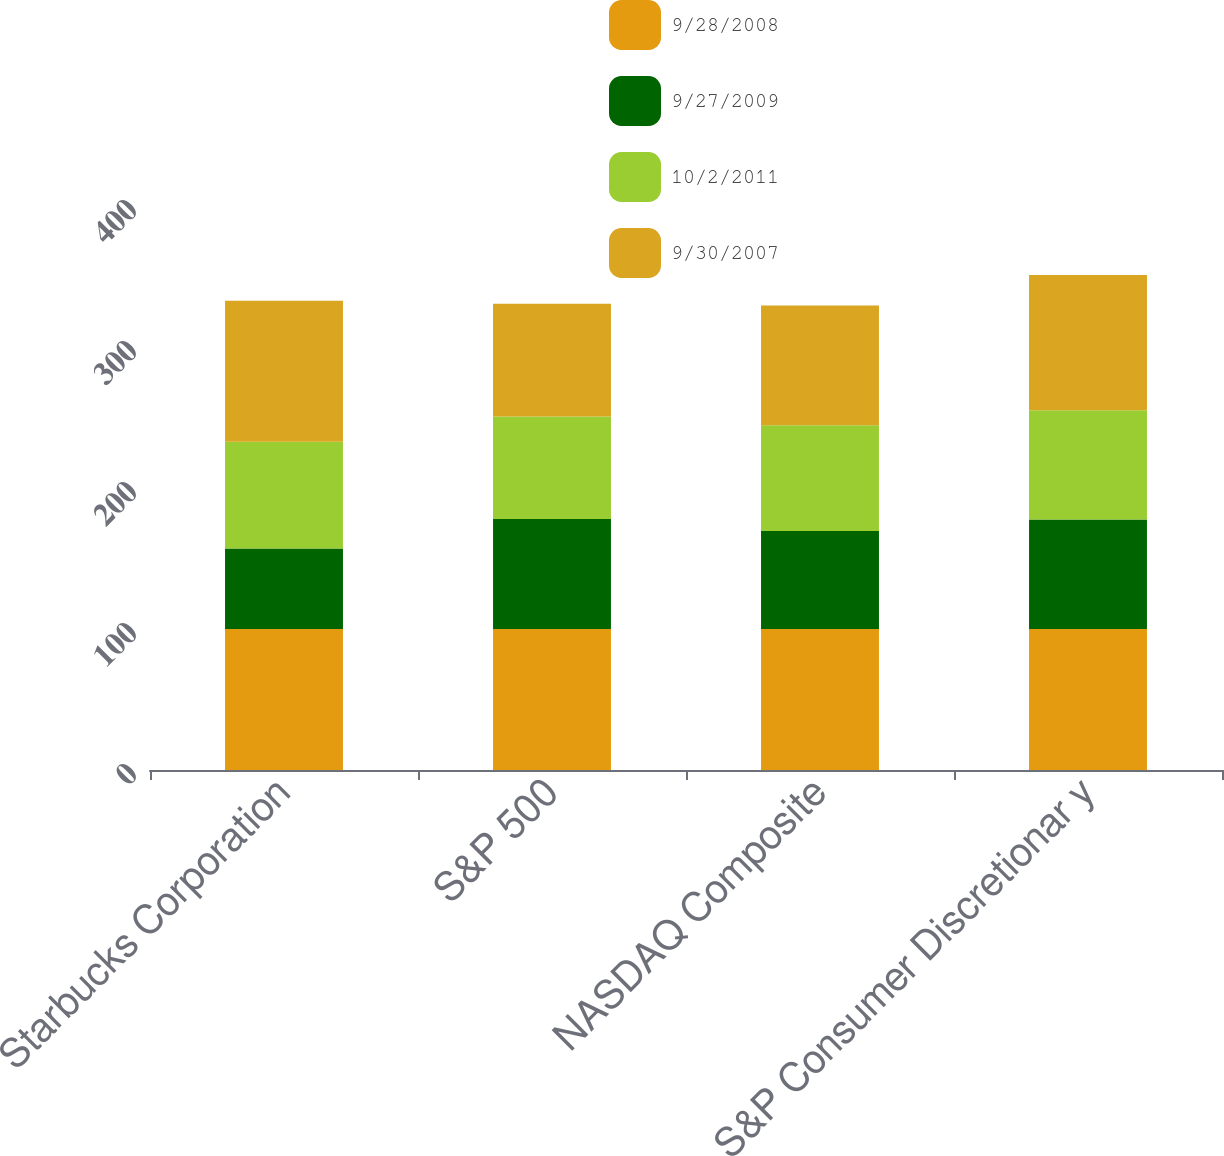Convert chart to OTSL. <chart><loc_0><loc_0><loc_500><loc_500><stacked_bar_chart><ecel><fcel>Starbucks Corporation<fcel>S&P 500<fcel>NASDAQ Composite<fcel>S&P Consumer Discretionar y<nl><fcel>9/28/2008<fcel>100<fcel>100<fcel>100<fcel>100<nl><fcel>9/27/2009<fcel>57.1<fcel>78.02<fcel>69.59<fcel>77.59<nl><fcel>10/2/2011<fcel>75.69<fcel>72.63<fcel>74.9<fcel>77.55<nl><fcel>9/30/2007<fcel>99.93<fcel>80.01<fcel>84.99<fcel>95.87<nl></chart> 